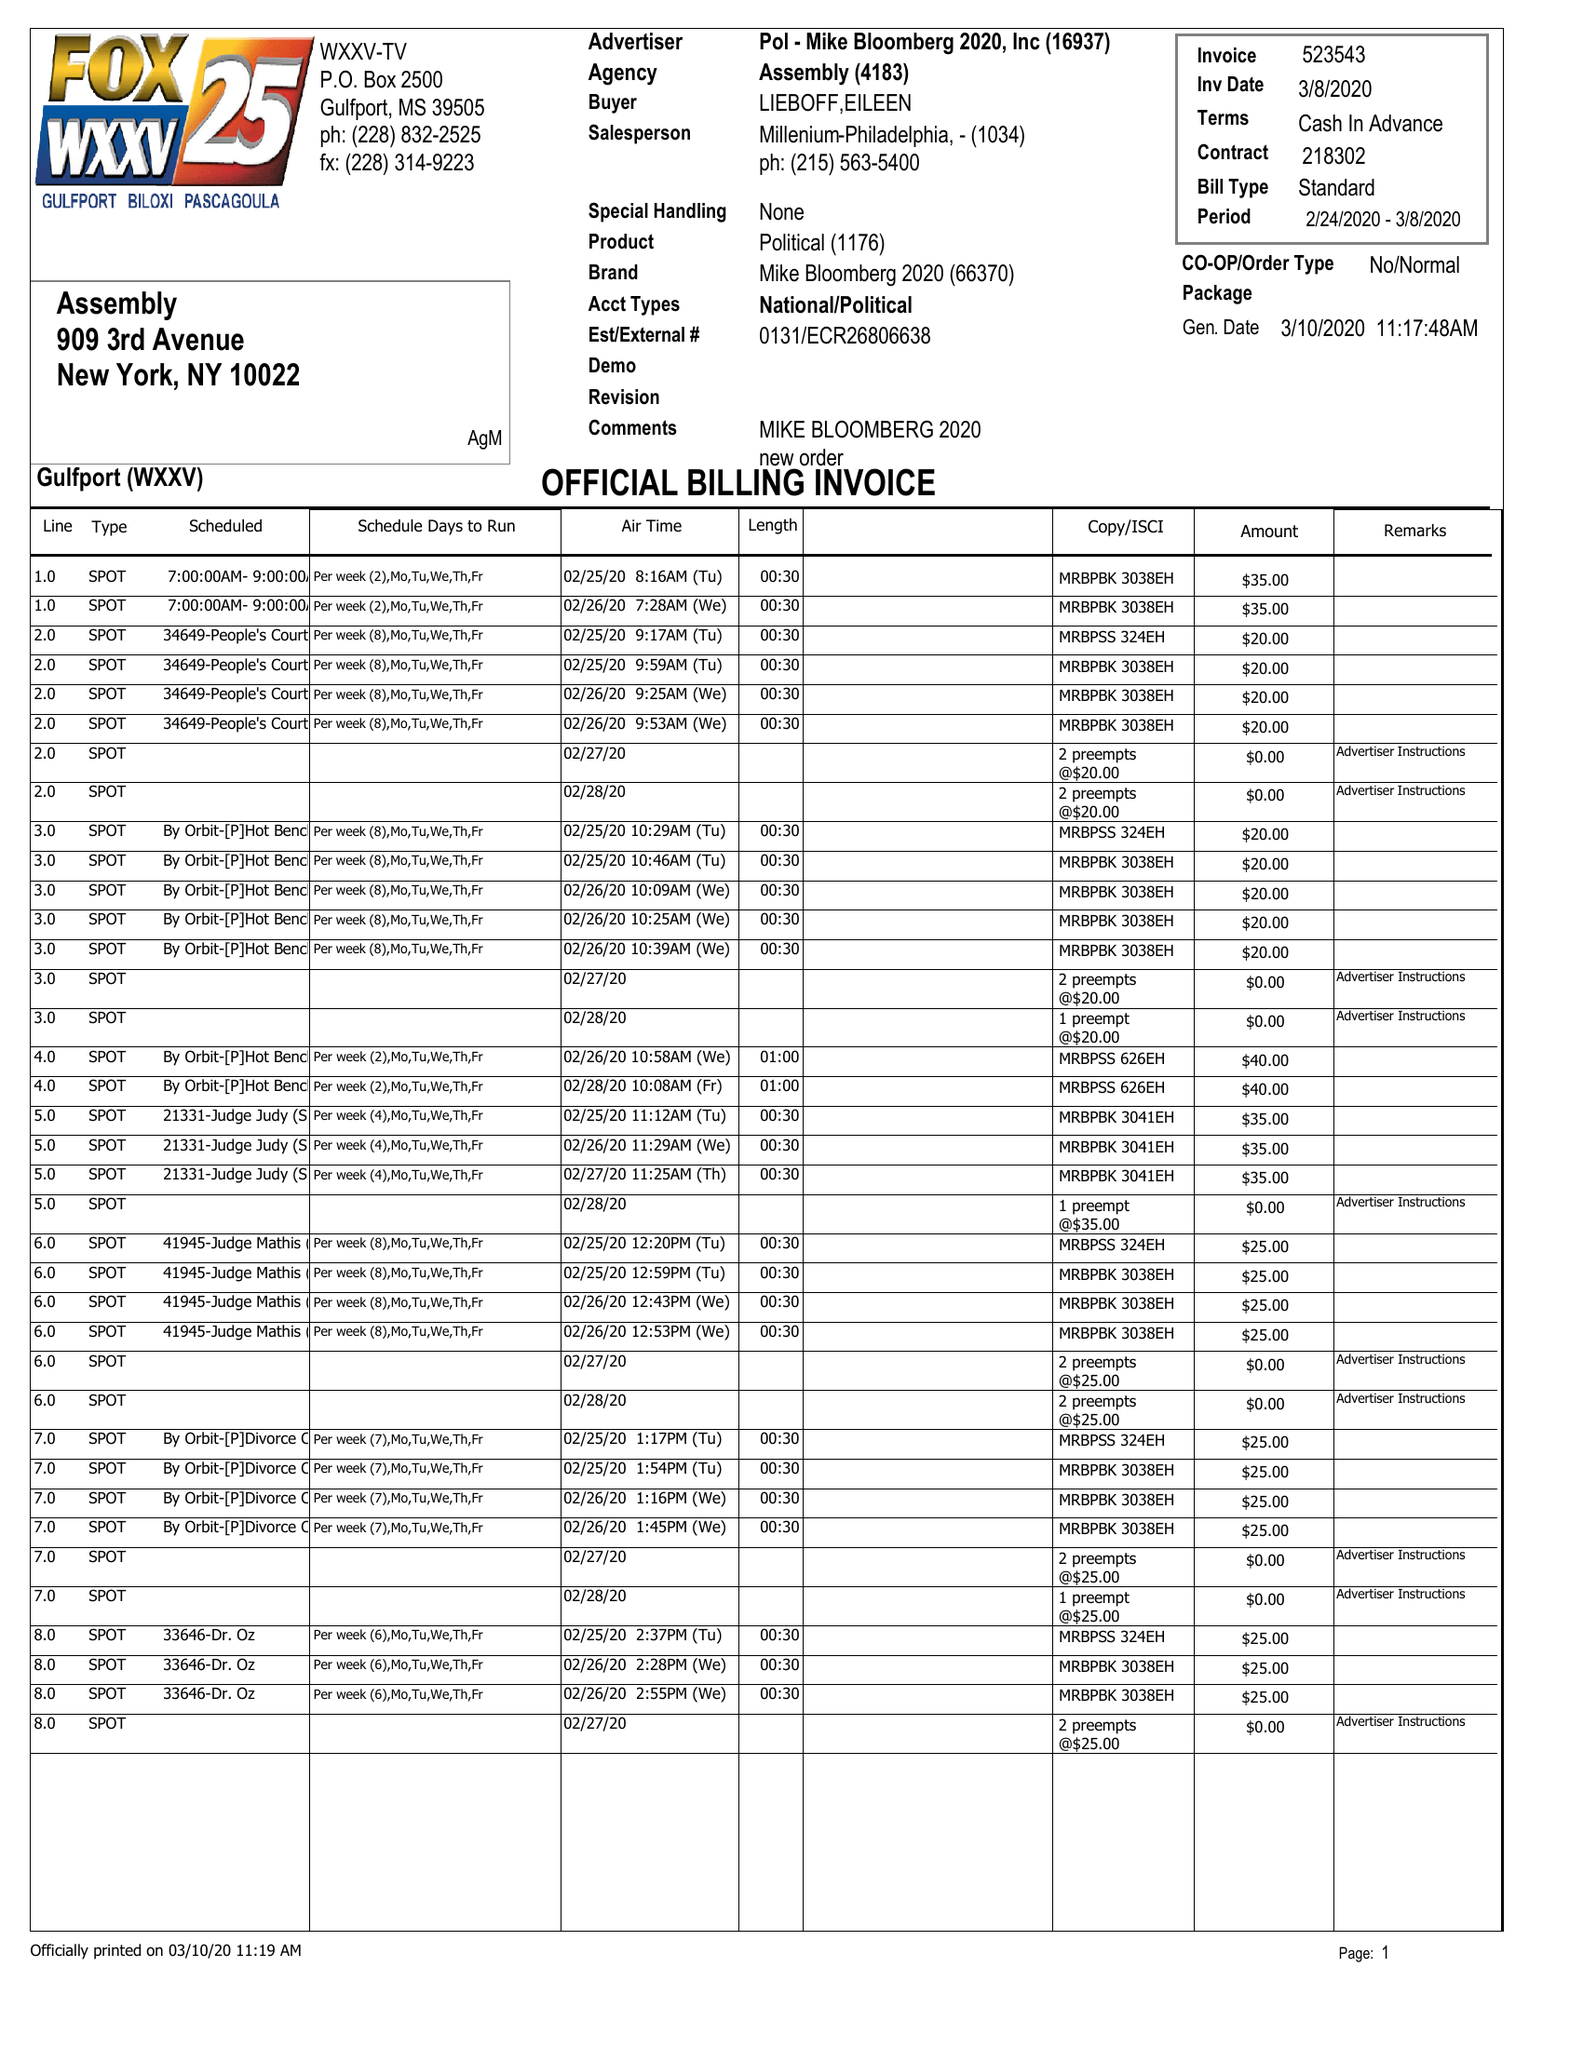What is the value for the gross_amount?
Answer the question using a single word or phrase. 5950.00 